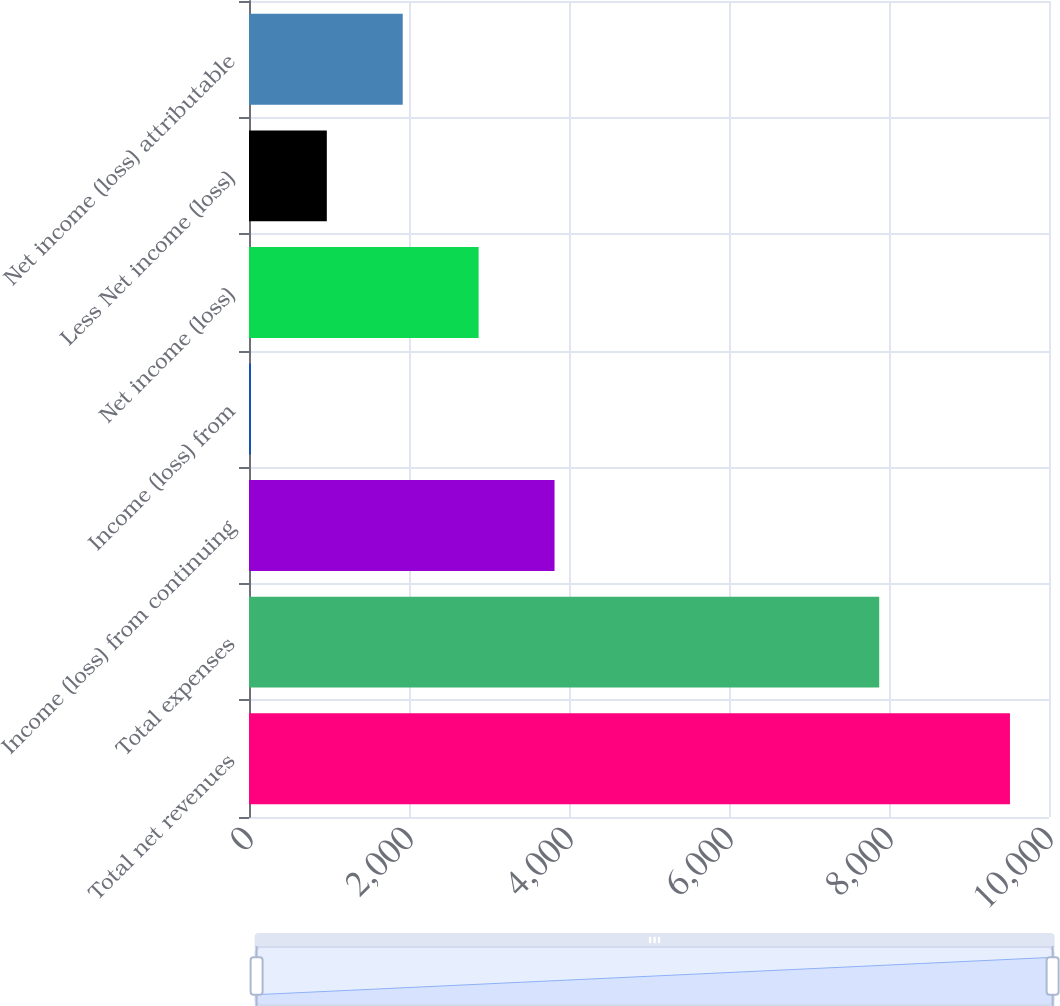Convert chart to OTSL. <chart><loc_0><loc_0><loc_500><loc_500><bar_chart><fcel>Total net revenues<fcel>Total expenses<fcel>Income (loss) from continuing<fcel>Income (loss) from<fcel>Net income (loss)<fcel>Less Net income (loss)<fcel>Net income (loss) attributable<nl><fcel>9512<fcel>7878<fcel>3819.2<fcel>24<fcel>2870.4<fcel>972.8<fcel>1921.6<nl></chart> 